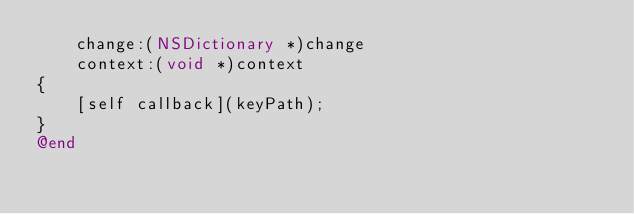<code> <loc_0><loc_0><loc_500><loc_500><_ObjectiveC_>    change:(NSDictionary *)change
    context:(void *)context
{
    [self callback](keyPath);
}
@end
</code> 